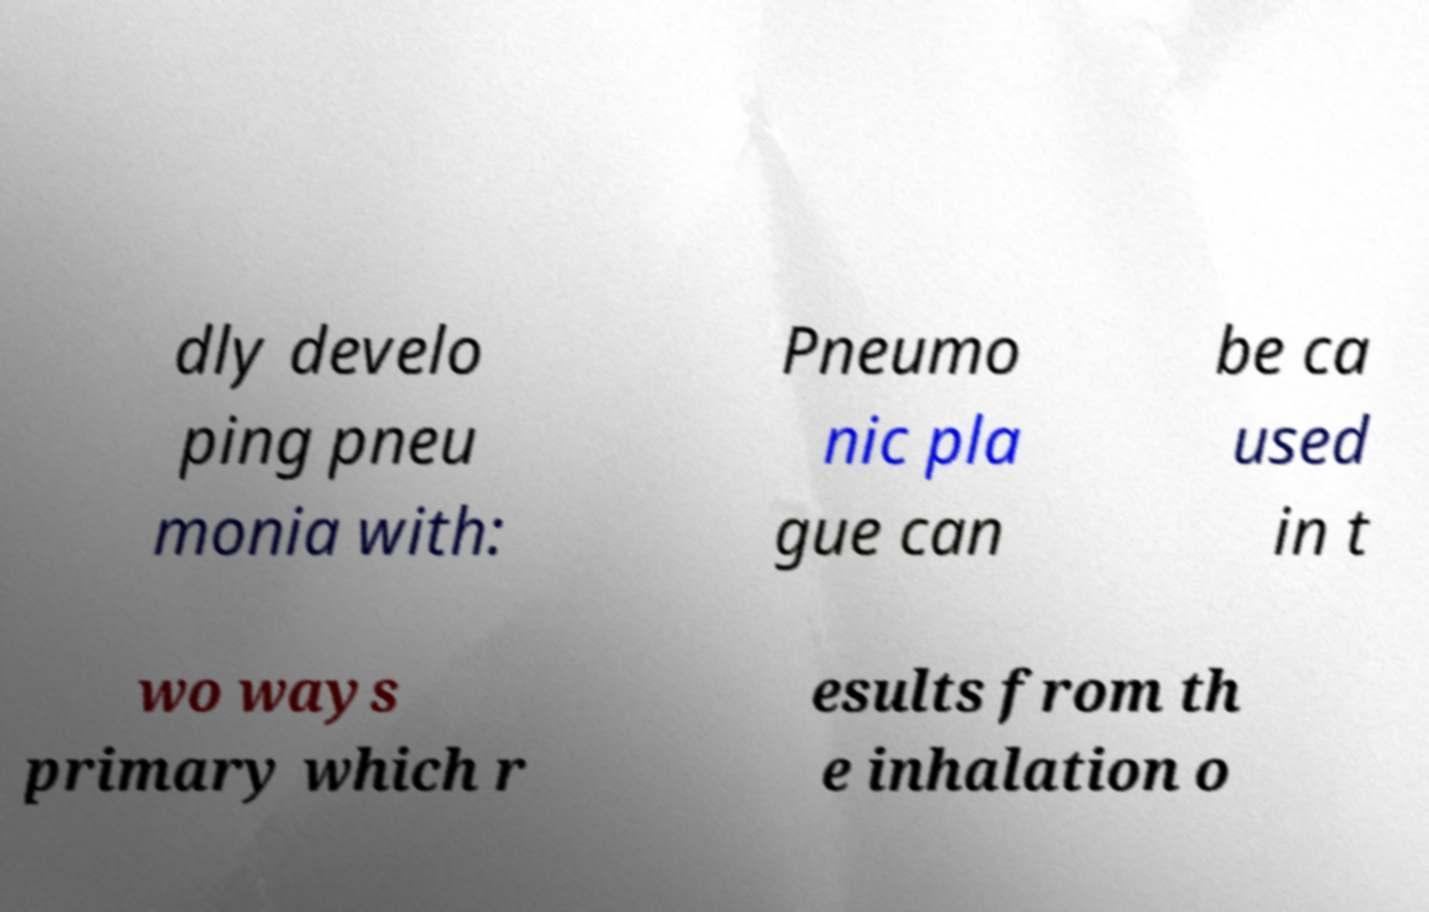What messages or text are displayed in this image? I need them in a readable, typed format. dly develo ping pneu monia with: Pneumo nic pla gue can be ca used in t wo ways primary which r esults from th e inhalation o 